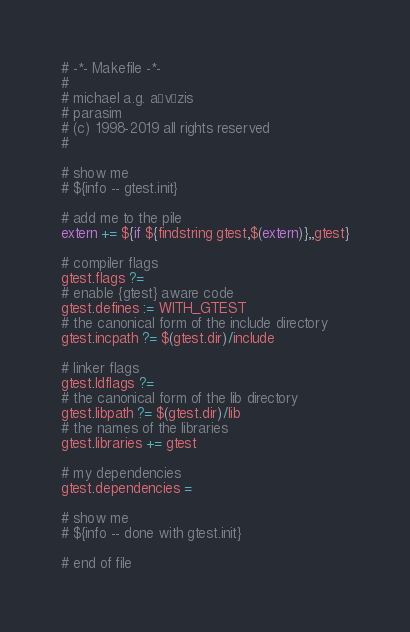<code> <loc_0><loc_0><loc_500><loc_500><_ObjectiveC_># -*- Makefile -*-
#
# michael a.g. aïvázis
# parasim
# (c) 1998-2019 all rights reserved
#

# show me
# ${info -- gtest.init}

# add me to the pile
extern += ${if ${findstring gtest,$(extern)},,gtest}

# compiler flags
gtest.flags ?=
# enable {gtest} aware code
gtest.defines := WITH_GTEST
# the canonical form of the include directory
gtest.incpath ?= $(gtest.dir)/include

# linker flags
gtest.ldflags ?=
# the canonical form of the lib directory
gtest.libpath ?= $(gtest.dir)/lib
# the names of the libraries
gtest.libraries += gtest

# my dependencies
gtest.dependencies =

# show me
# ${info -- done with gtest.init}

# end of file
</code> 